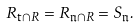Convert formula to latex. <formula><loc_0><loc_0><loc_500><loc_500>R _ { \mathfrak { t } \cap R } = R _ { \mathfrak { n } \cap R } = S _ { \mathfrak { n } } .</formula> 